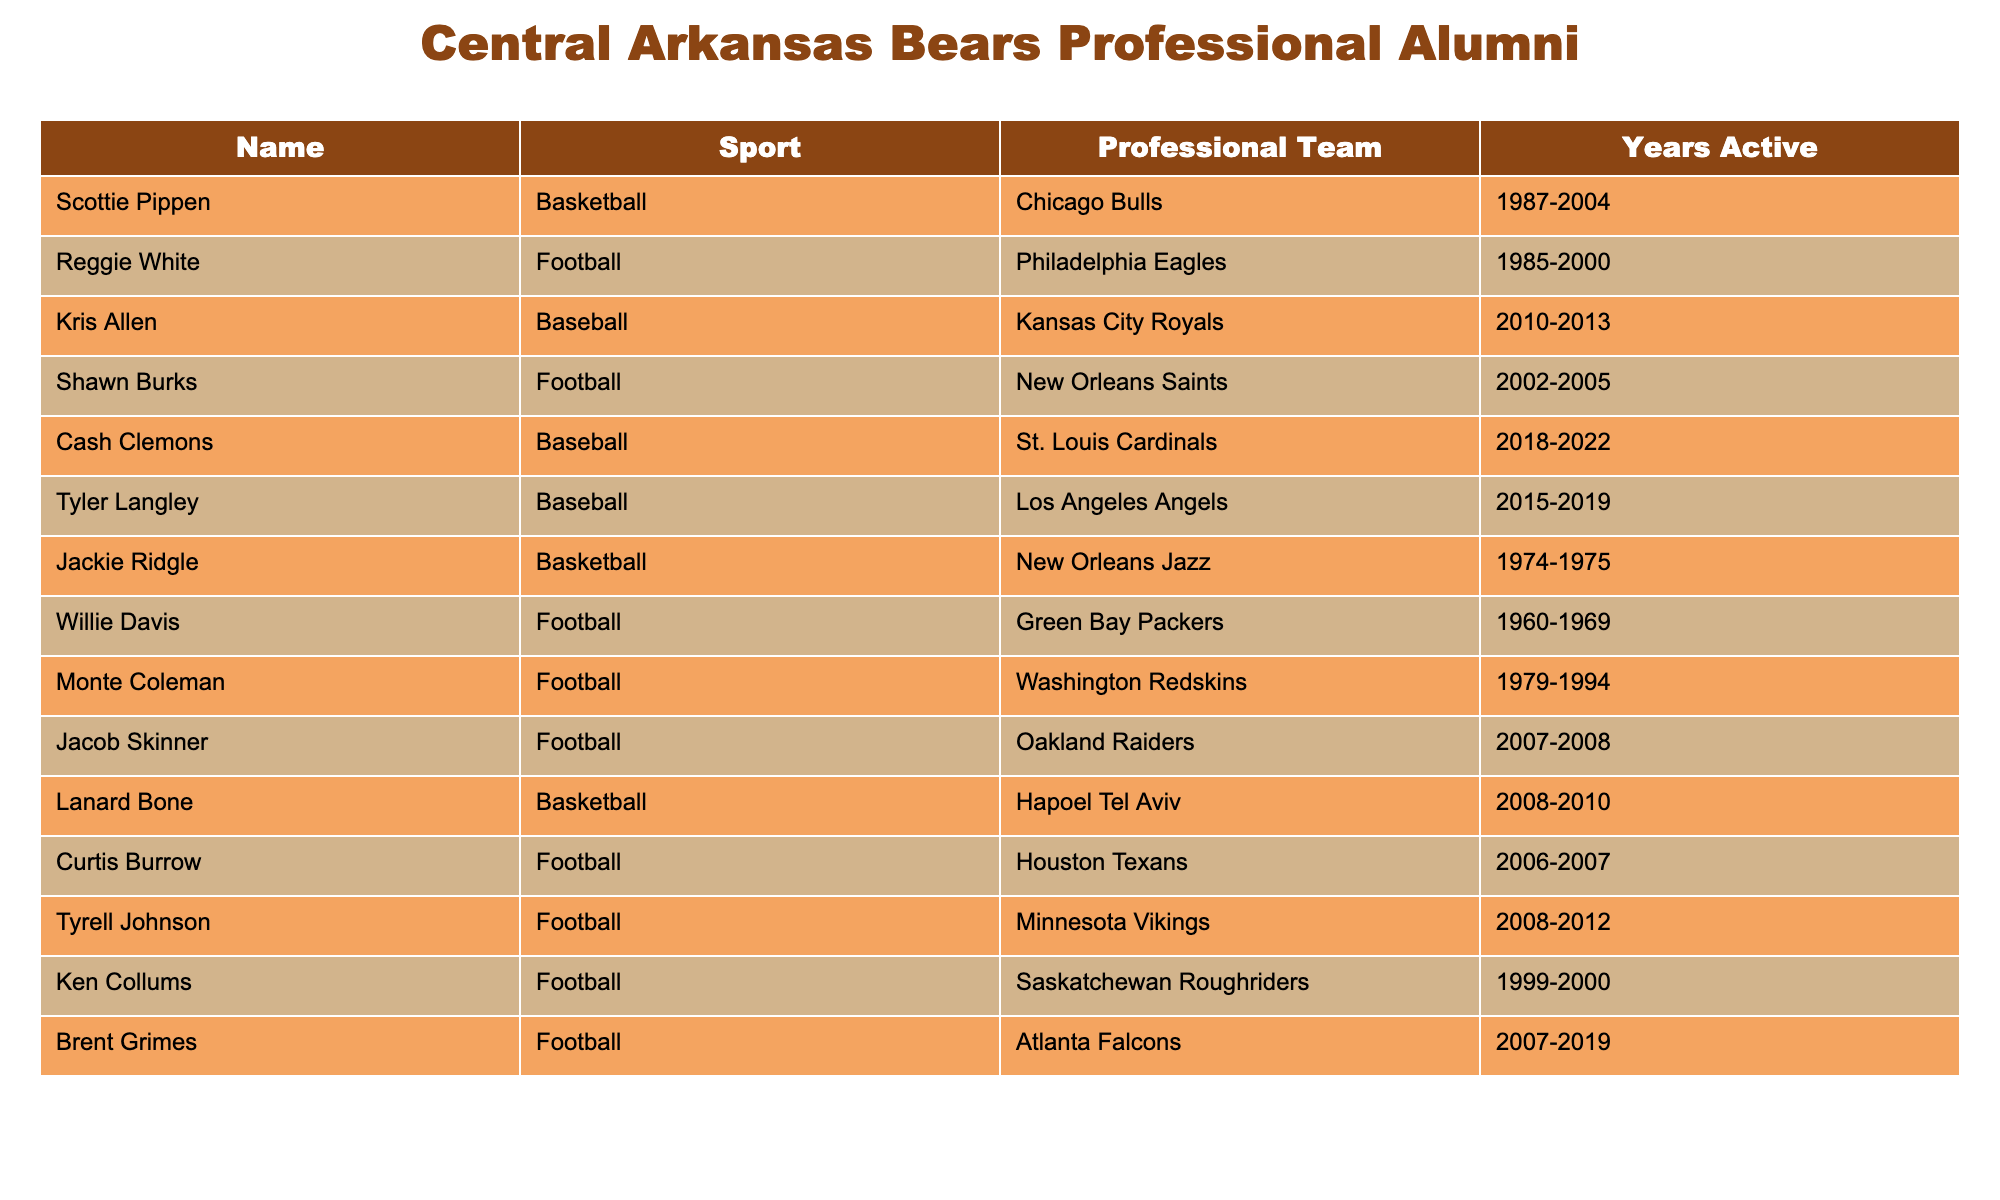What sport did Scottie Pippen play? Scottie Pippen is listed under the column for Sport, and it indicates that he played Basketball.
Answer: Basketball Which professional team did Reggie White play for? The table shows that Reggie White played for the Philadelphia Eagles, as indicated in the Professional Team column next to his name.
Answer: Philadelphia Eagles How many years did Tyler Langley play professionally? According to the Years Active column, Tyler Langley played from 2015 to 2019, making it a total of 4 years.
Answer: 4 years Did any alumni from Central Arkansas Bears play in the NFL? By reviewing the table, we see several names listed under the Sport Football, indicating that yes, there are alumni who played in the NFL.
Answer: Yes Who played Baseball for the St. Louis Cardinals? The table indicates that Cash Clemons played Baseball for the St. Louis Cardinals, as shown in the Professional Team column.
Answer: Cash Clemons Which sport had the greatest number of listed alumni? Examining the table, Football appears to have the most entries with a total of 6 alumni, compared to Basketball and Baseball with 3 each.
Answer: Football Is there an alumni who played Basketball in the NBA? The table shows Scottie Pippen and Jackie Ridgle as alumni who played Basketball, and since Scottie Pippen is a well-known NBA player, the answer is yes.
Answer: Yes What is the range of years active for the alumni listed in the table? The earliest years active starts from 1960 (Willie Davis) and goes until 2022 (Cash Clemons), making the range from 1960 to 2022.
Answer: 1960 to 2022 Which professional football team had the most listed alumni from this table? Looking at the table, the Philadelphia Eagles and New Orleans Saints each have one listed alumnus, while other teams like the Green Bay Packers, Washington Redskins, and Minnesota Vikings also have one alumni, making it a tie with no team possessing a larger number.
Answer: No team has more alumni What was the total number of years played by all Football alumni combined? By adding up the years for all football players: 15 (Reggie White) + 4 (Shawn Burks) + 2 (Curtis Burrow) + 4 (Tyrell Johnson) + 1 (Ken Collums) + 12 (Monte Coleman) + 2 (Jacob Skinner) + 12 (Brent Grimes) = 53 years total.
Answer: 53 years 